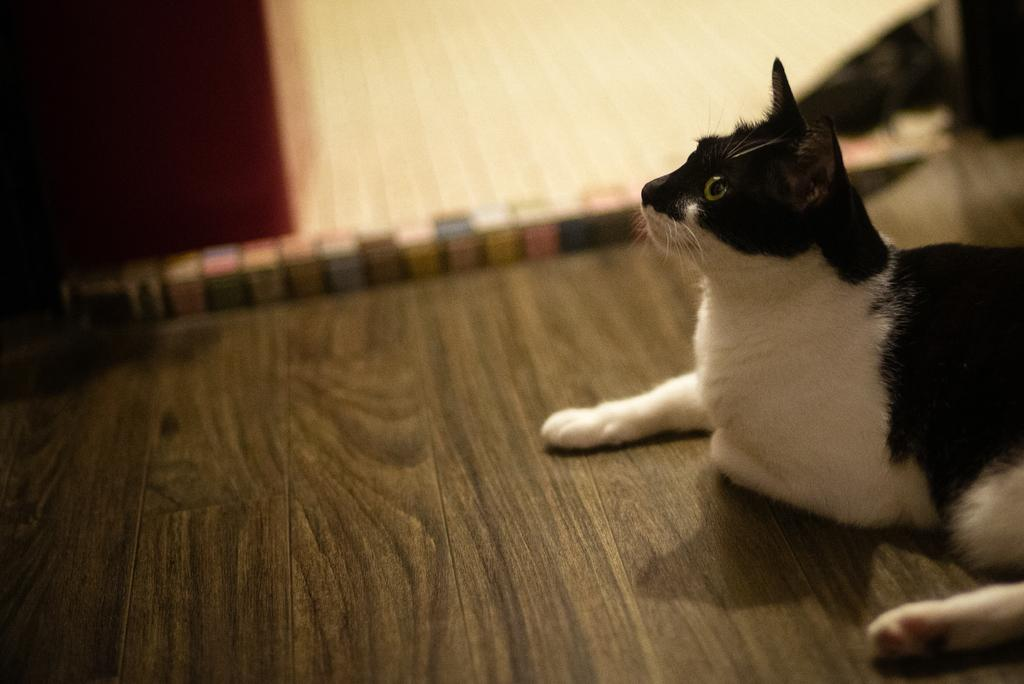What type of animal is in the image? There is a cat in the image. What colors can be seen on the cat? The cat is black and white in color. Where is the cat located in the image? The cat is resting on the floor. Can you see the cat's wings in the image? No, there are no wings visible on the cat in the image. 